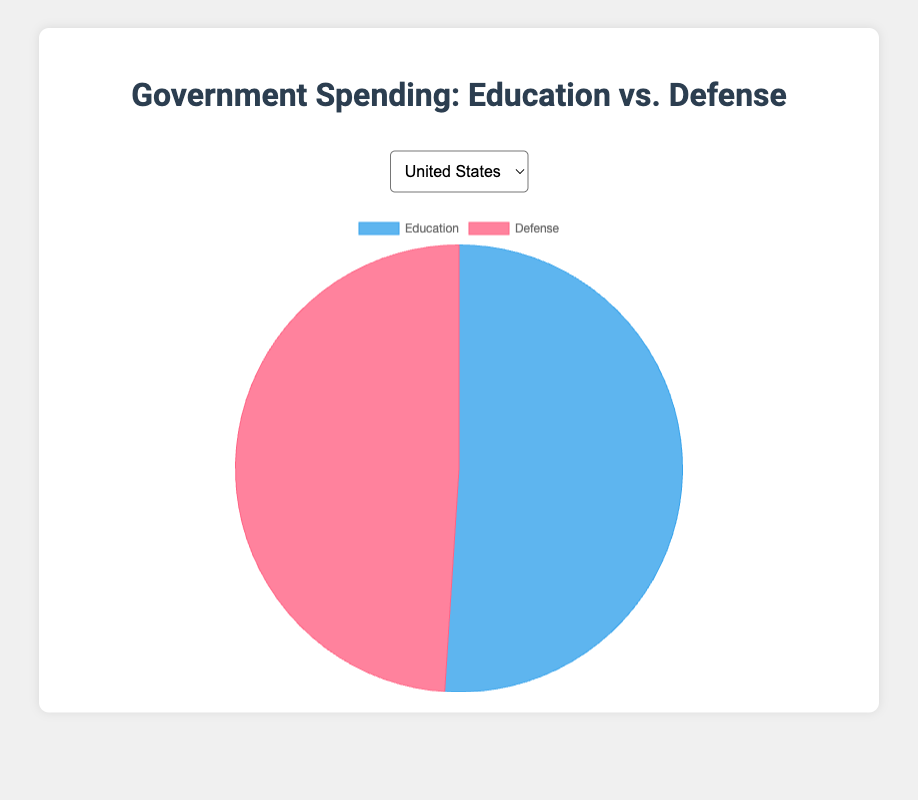What percentage of government spending is allocated to Education in Germany? First, identify total spending: Education (500) + Defense (250) = 750. The percentage is calculated as (Education / Total) x 100 = (500 / 750) x 100 = ~66.67%
Answer: ~66.67% Which country spends more on Defense, the United States or Japan? The Defense spending of the United States is 720 and Japan is 240. By comparing these values, the United States spends more on Defense.
Answer: United States What is the difference in Defense spending between India and Canada? India's Defense spending is 200 and Canada's Defense spending is also 200. The difference is calculated as DefenseIndia - DefenseCanada = 200 - 200 = 0
Answer: 0 How much more does Canada spend on Education compared to India? Canada's Education spending is 300 and India's Education spending is 225. The difference is calculated as EducationCanada - EducationIndia = 300 - 225 = 75
Answer: 75 What proportion of Japan's spending is on Defense? First, identify total spending: Education (400) + Defense (240) = 640. Proportionate spending on Defense is (Defense / Total) = 240 / 640 = 0.375 or 37.5%
Answer: 37.5% Compare the visual representation of Education spending in the United States to that of Defense spending in Germany. The pie chart shows that the Education segment for the US is larger than the Defense segment for Germany since 750 is greater than 250.
Answer: Education segment of US is larger Which country's pie chart segments for Education and Defense are closest in size? Compare the relative sizes visually. The United States has Education (750) and Defense (720), resulting in nearly equal-sized segments.
Answer: United States What is the total government spending on Education for all listed countries combined? Sum the Education values for all countries: 750 (US) + 500 (Germany) + 225 (India) + 300 (Canada) + 400 (Japan) = 2175
Answer: 2175 Is the proportion of Defense spending higher in Germany or Japan? Calculate proportions: Germany’s Defense (250) / Total (750) = ~33.33%; Japan’s Defense (240) / Total (640) = 37.5%. Japan's proportion is higher.
Answer: Japan How many countries have a higher allocation for Education than Defense? Compare the spending: United States (750 > 720), Germany (500 > 250), India (225 > 200), Canada (300 > 200), Japan (400 > 240). All 5 countries spend more on Education than Defense.
Answer: 5 